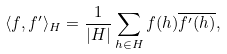<formula> <loc_0><loc_0><loc_500><loc_500>\langle f , f ^ { \prime } \rangle _ { H } = \frac { 1 } { | H | } \sum _ { h \in H } f ( h ) \overline { f ^ { \prime } ( h ) } ,</formula> 